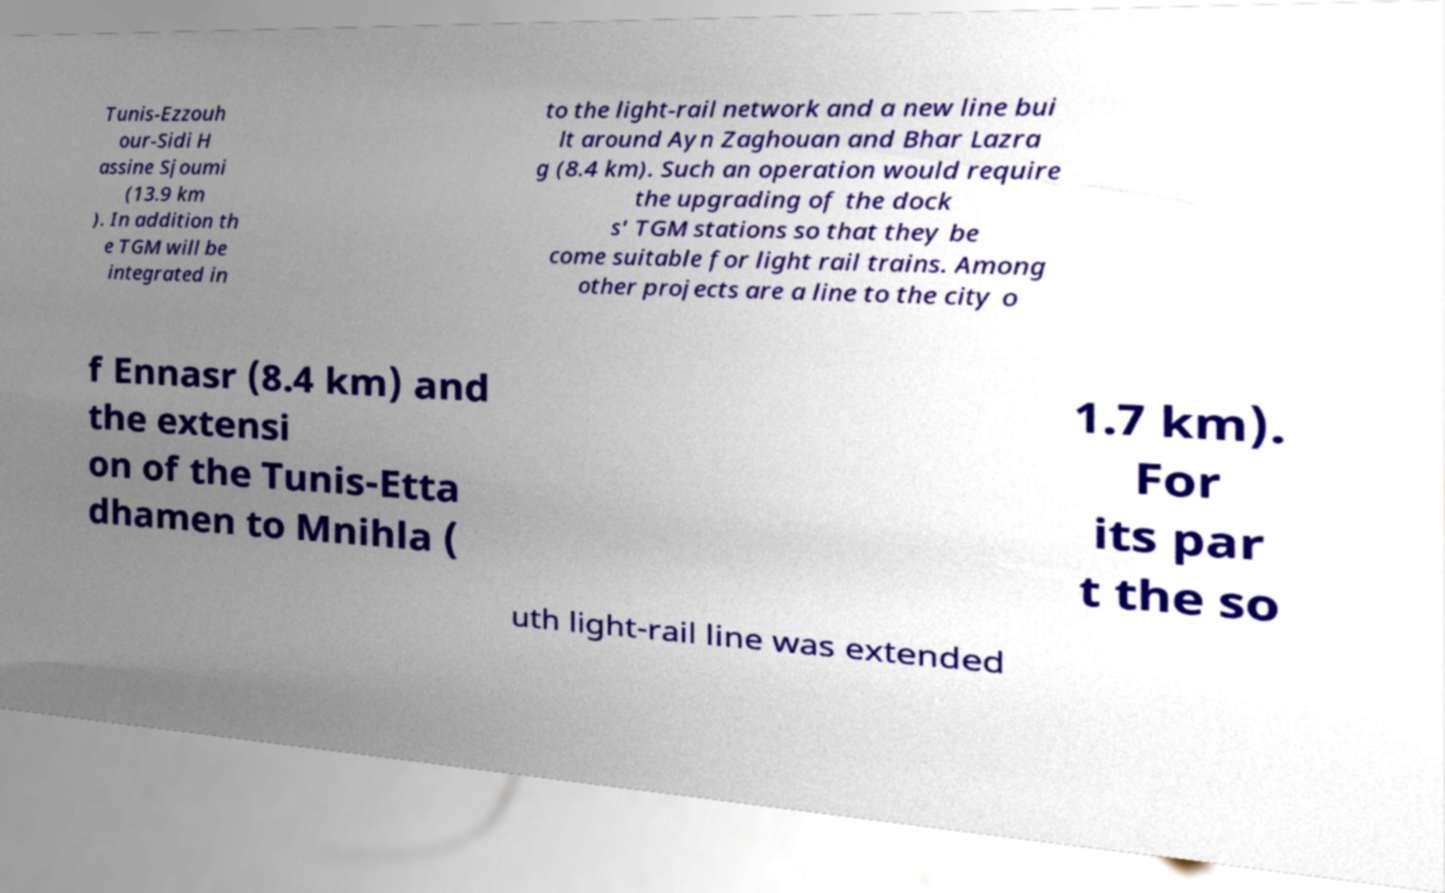Please read and relay the text visible in this image. What does it say? Tunis-Ezzouh our-Sidi H assine Sjoumi (13.9 km ). In addition th e TGM will be integrated in to the light-rail network and a new line bui lt around Ayn Zaghouan and Bhar Lazra g (8.4 km). Such an operation would require the upgrading of the dock s' TGM stations so that they be come suitable for light rail trains. Among other projects are a line to the city o f Ennasr (8.4 km) and the extensi on of the Tunis-Etta dhamen to Mnihla ( 1.7 km). For its par t the so uth light-rail line was extended 